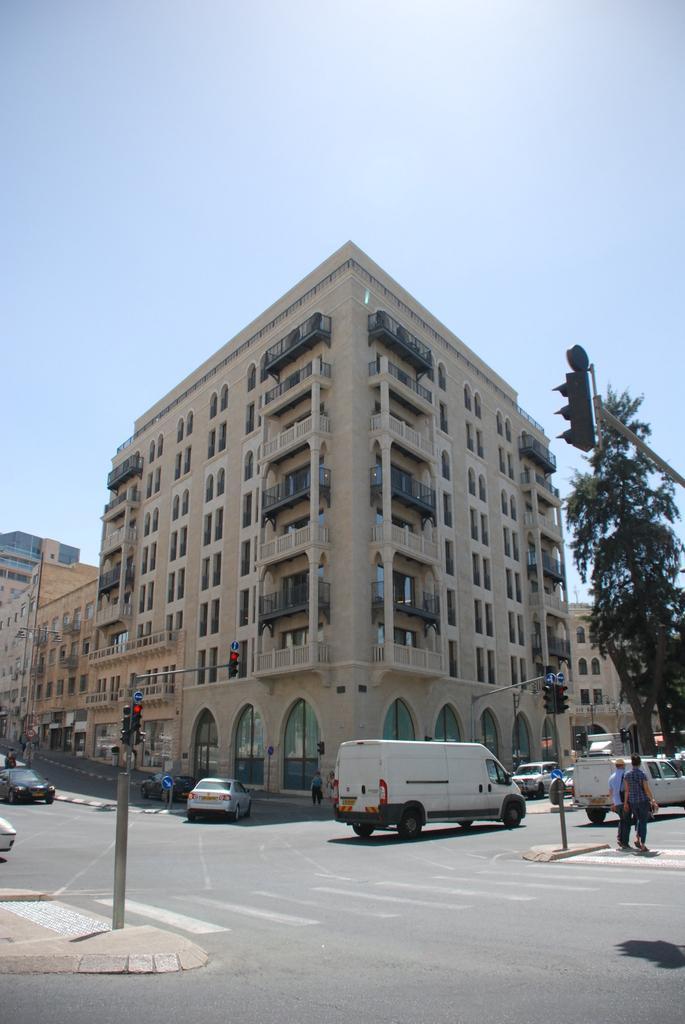In one or two sentences, can you explain what this image depicts? In this image there is a road in the middle. On the road there are so many cars. In the background there are buildings. On the right side there is a tree. Beside the tree there is a traffic signal light. At the top there is the sky. On the left side bottom there is a footpath on which there is a pole. 